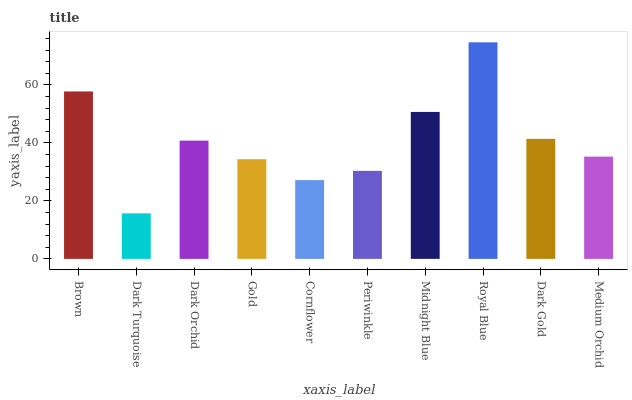Is Dark Turquoise the minimum?
Answer yes or no. Yes. Is Royal Blue the maximum?
Answer yes or no. Yes. Is Dark Orchid the minimum?
Answer yes or no. No. Is Dark Orchid the maximum?
Answer yes or no. No. Is Dark Orchid greater than Dark Turquoise?
Answer yes or no. Yes. Is Dark Turquoise less than Dark Orchid?
Answer yes or no. Yes. Is Dark Turquoise greater than Dark Orchid?
Answer yes or no. No. Is Dark Orchid less than Dark Turquoise?
Answer yes or no. No. Is Dark Orchid the high median?
Answer yes or no. Yes. Is Medium Orchid the low median?
Answer yes or no. Yes. Is Medium Orchid the high median?
Answer yes or no. No. Is Cornflower the low median?
Answer yes or no. No. 